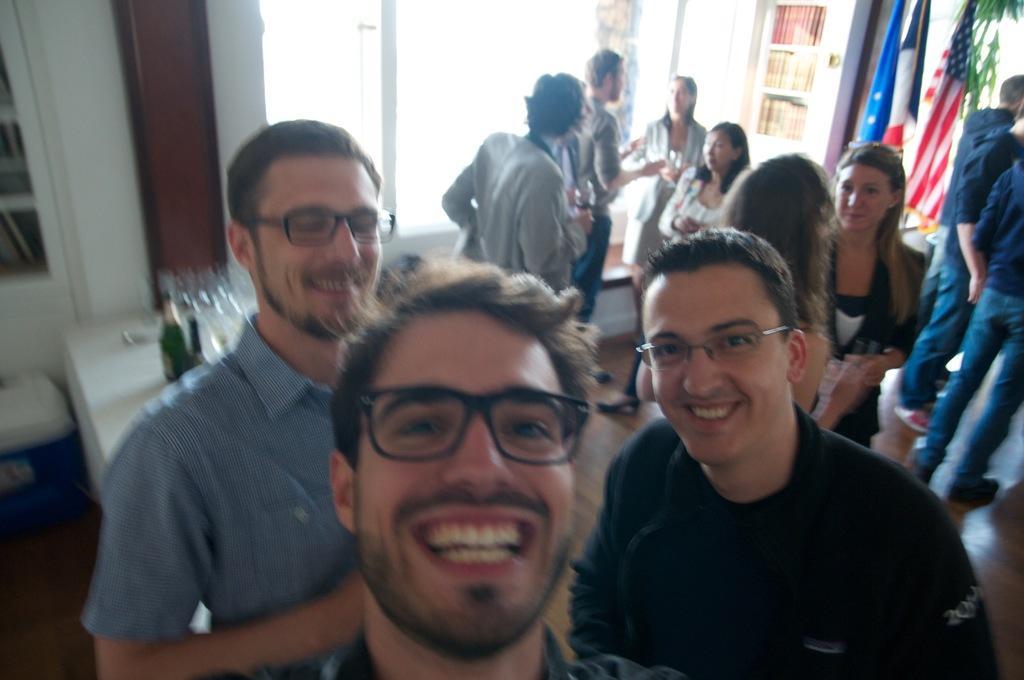Describe this image in one or two sentences. This is an inside view. Here I can see three men smiling and giving pose for the picture. On the right side there are some more people standing. On the left side there is a table on which few bottles and glasses are placed. In the background there is a window to the wall and also there is a rack. On the right side there are three flags and few leaves are visible. 